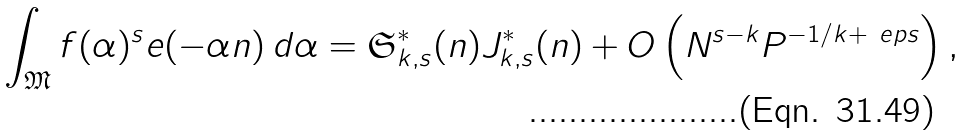Convert formula to latex. <formula><loc_0><loc_0><loc_500><loc_500>\int _ { \mathfrak M } f ( \alpha ) ^ { s } e ( - \alpha n ) \, d \alpha = \mathfrak S _ { k , s } ^ { * } ( n ) J _ { k , s } ^ { * } ( n ) + O \left ( N ^ { s - k } P ^ { - 1 / k + \ e p s } \right ) ,</formula> 